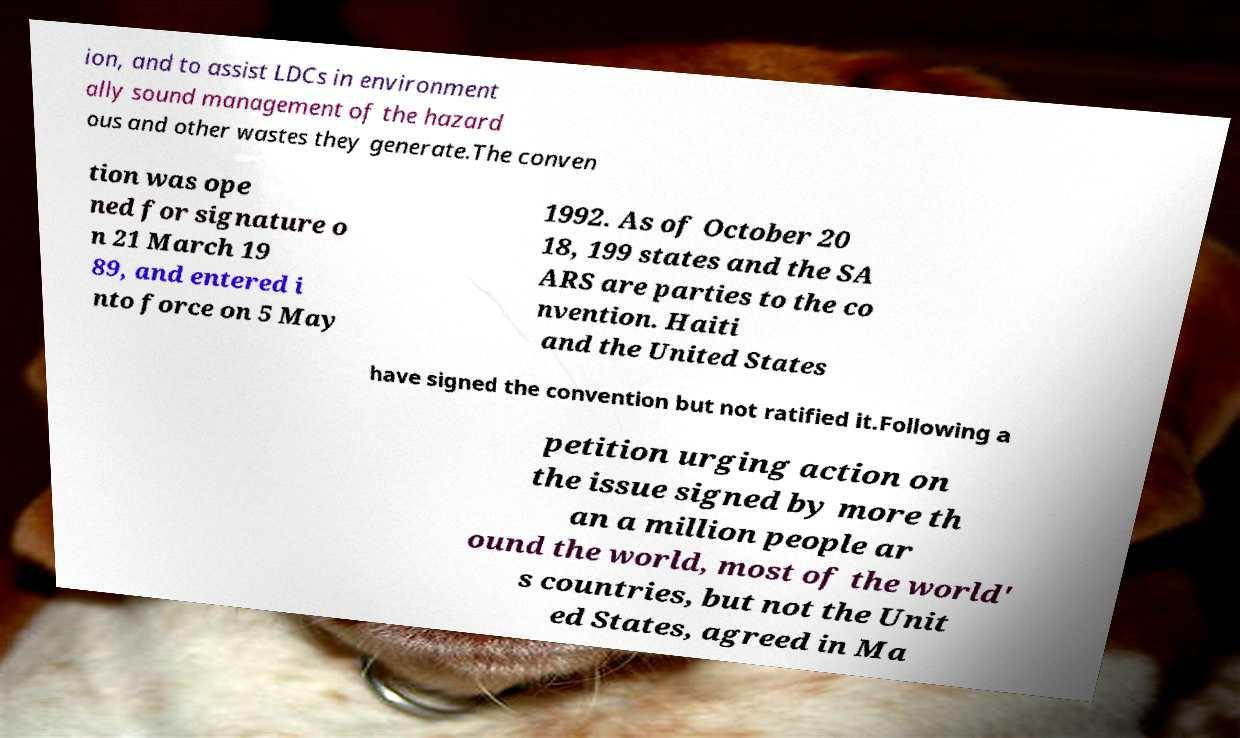I need the written content from this picture converted into text. Can you do that? ion, and to assist LDCs in environment ally sound management of the hazard ous and other wastes they generate.The conven tion was ope ned for signature o n 21 March 19 89, and entered i nto force on 5 May 1992. As of October 20 18, 199 states and the SA ARS are parties to the co nvention. Haiti and the United States have signed the convention but not ratified it.Following a petition urging action on the issue signed by more th an a million people ar ound the world, most of the world' s countries, but not the Unit ed States, agreed in Ma 